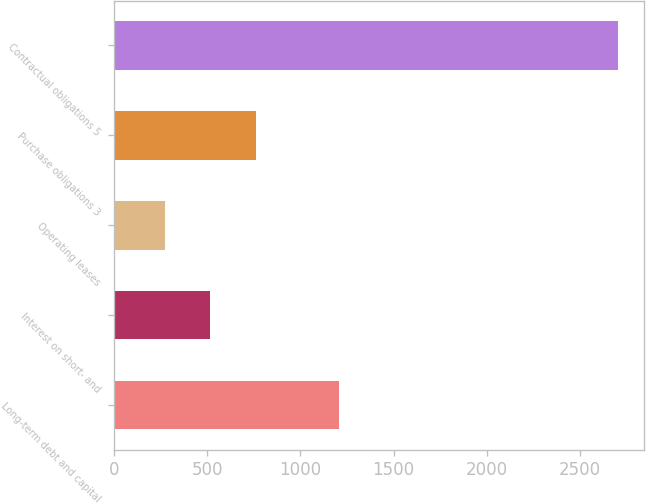Convert chart to OTSL. <chart><loc_0><loc_0><loc_500><loc_500><bar_chart><fcel>Long-term debt and capital<fcel>Interest on short- and<fcel>Operating leases<fcel>Purchase obligations 3<fcel>Contractual obligations 5<nl><fcel>1205<fcel>517.2<fcel>274<fcel>760.4<fcel>2706<nl></chart> 